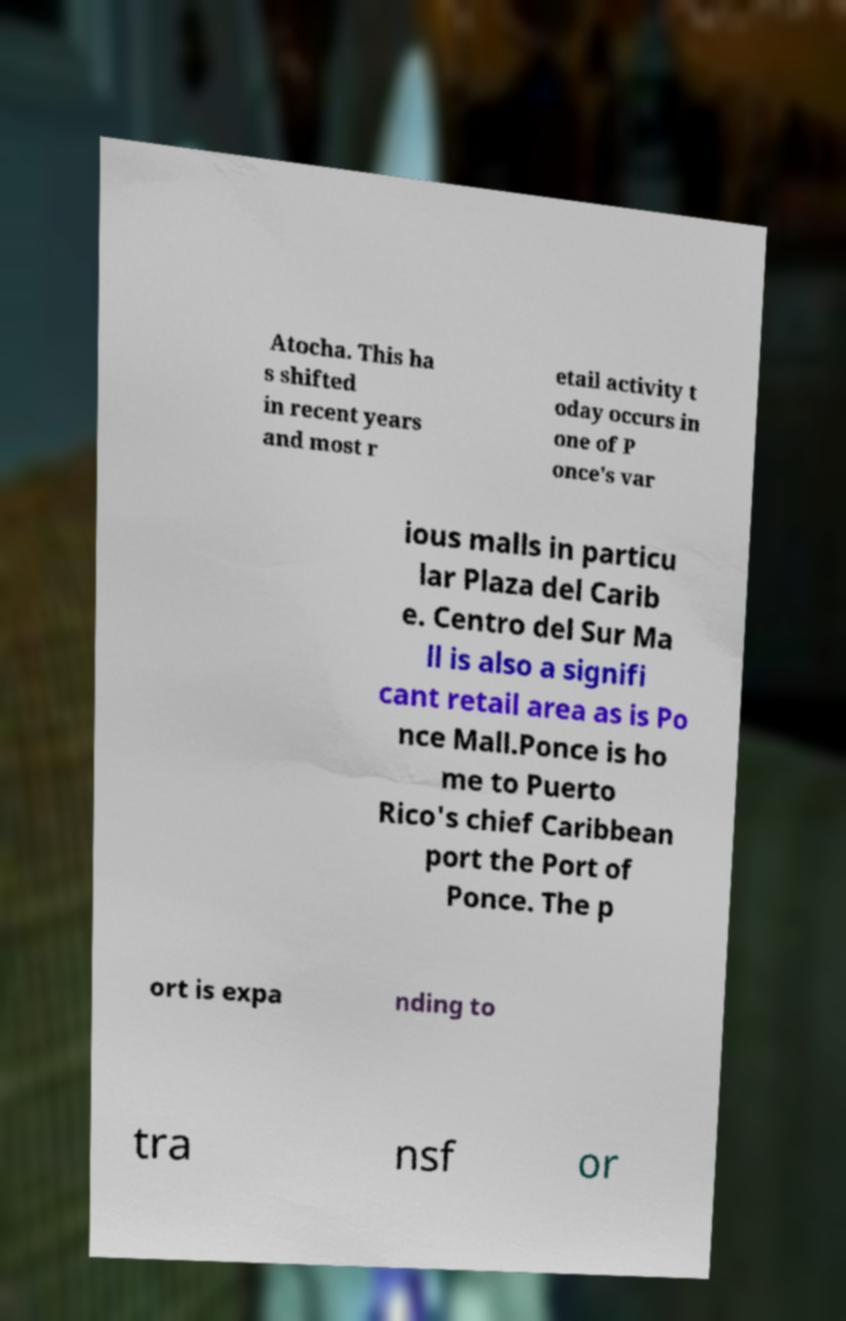Can you read and provide the text displayed in the image?This photo seems to have some interesting text. Can you extract and type it out for me? Atocha. This ha s shifted in recent years and most r etail activity t oday occurs in one of P once's var ious malls in particu lar Plaza del Carib e. Centro del Sur Ma ll is also a signifi cant retail area as is Po nce Mall.Ponce is ho me to Puerto Rico's chief Caribbean port the Port of Ponce. The p ort is expa nding to tra nsf or 